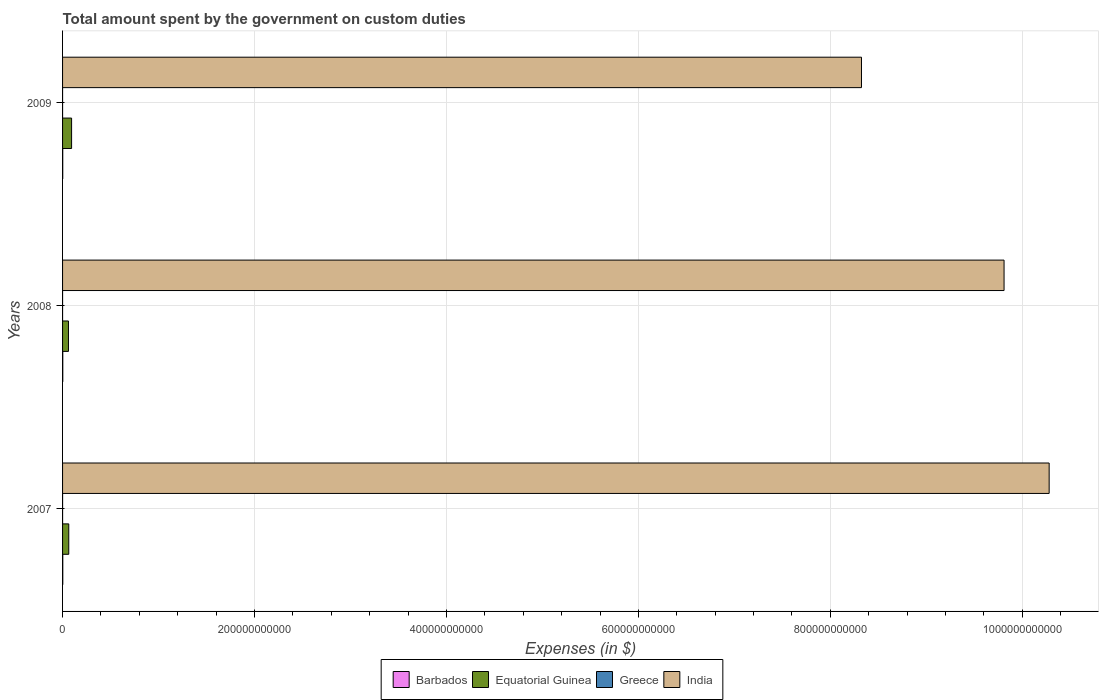How many different coloured bars are there?
Keep it short and to the point. 4. How many groups of bars are there?
Offer a terse response. 3. Are the number of bars on each tick of the Y-axis equal?
Your answer should be compact. Yes. How many bars are there on the 3rd tick from the bottom?
Make the answer very short. 4. What is the label of the 1st group of bars from the top?
Make the answer very short. 2009. What is the amount spent on custom duties by the government in Equatorial Guinea in 2007?
Provide a succinct answer. 6.46e+09. Across all years, what is the maximum amount spent on custom duties by the government in Equatorial Guinea?
Offer a terse response. 9.40e+09. Across all years, what is the minimum amount spent on custom duties by the government in Barbados?
Your response must be concise. 1.78e+08. In which year was the amount spent on custom duties by the government in Greece maximum?
Keep it short and to the point. 2007. What is the total amount spent on custom duties by the government in Greece in the graph?
Ensure brevity in your answer.  1.00e+07. What is the difference between the amount spent on custom duties by the government in Barbados in 2007 and that in 2008?
Provide a short and direct response. -2.52e+06. What is the difference between the amount spent on custom duties by the government in Equatorial Guinea in 2009 and the amount spent on custom duties by the government in India in 2007?
Keep it short and to the point. -1.02e+12. What is the average amount spent on custom duties by the government in Barbados per year?
Provide a succinct answer. 2.05e+08. In the year 2007, what is the difference between the amount spent on custom duties by the government in Equatorial Guinea and amount spent on custom duties by the government in Greece?
Your response must be concise. 6.45e+09. In how many years, is the amount spent on custom duties by the government in Barbados greater than 720000000000 $?
Your response must be concise. 0. What is the ratio of the amount spent on custom duties by the government in Barbados in 2007 to that in 2009?
Keep it short and to the point. 1.22. Is the amount spent on custom duties by the government in Equatorial Guinea in 2007 less than that in 2009?
Offer a terse response. Yes. What is the difference between the highest and the second highest amount spent on custom duties by the government in India?
Provide a succinct answer. 4.70e+1. What is the difference between the highest and the lowest amount spent on custom duties by the government in Barbados?
Provide a succinct answer. 4.15e+07. What does the 2nd bar from the bottom in 2008 represents?
Give a very brief answer. Equatorial Guinea. Is it the case that in every year, the sum of the amount spent on custom duties by the government in Barbados and amount spent on custom duties by the government in Greece is greater than the amount spent on custom duties by the government in Equatorial Guinea?
Ensure brevity in your answer.  No. Are all the bars in the graph horizontal?
Your answer should be very brief. Yes. What is the difference between two consecutive major ticks on the X-axis?
Provide a short and direct response. 2.00e+11. Are the values on the major ticks of X-axis written in scientific E-notation?
Provide a short and direct response. No. Does the graph contain any zero values?
Your response must be concise. No. Where does the legend appear in the graph?
Your answer should be compact. Bottom center. How many legend labels are there?
Give a very brief answer. 4. How are the legend labels stacked?
Ensure brevity in your answer.  Horizontal. What is the title of the graph?
Your response must be concise. Total amount spent by the government on custom duties. Does "Arab World" appear as one of the legend labels in the graph?
Give a very brief answer. No. What is the label or title of the X-axis?
Make the answer very short. Expenses (in $). What is the Expenses (in $) of Barbados in 2007?
Offer a terse response. 2.17e+08. What is the Expenses (in $) in Equatorial Guinea in 2007?
Offer a very short reply. 6.46e+09. What is the Expenses (in $) in India in 2007?
Provide a succinct answer. 1.03e+12. What is the Expenses (in $) in Barbados in 2008?
Offer a very short reply. 2.19e+08. What is the Expenses (in $) in Equatorial Guinea in 2008?
Your response must be concise. 6.14e+09. What is the Expenses (in $) in India in 2008?
Your answer should be compact. 9.81e+11. What is the Expenses (in $) in Barbados in 2009?
Provide a short and direct response. 1.78e+08. What is the Expenses (in $) in Equatorial Guinea in 2009?
Make the answer very short. 9.40e+09. What is the Expenses (in $) in Greece in 2009?
Provide a succinct answer. 1.00e+06. What is the Expenses (in $) of India in 2009?
Offer a terse response. 8.32e+11. Across all years, what is the maximum Expenses (in $) in Barbados?
Make the answer very short. 2.19e+08. Across all years, what is the maximum Expenses (in $) in Equatorial Guinea?
Offer a terse response. 9.40e+09. Across all years, what is the maximum Expenses (in $) of Greece?
Your answer should be very brief. 7.00e+06. Across all years, what is the maximum Expenses (in $) of India?
Offer a terse response. 1.03e+12. Across all years, what is the minimum Expenses (in $) in Barbados?
Provide a short and direct response. 1.78e+08. Across all years, what is the minimum Expenses (in $) of Equatorial Guinea?
Give a very brief answer. 6.14e+09. Across all years, what is the minimum Expenses (in $) of India?
Ensure brevity in your answer.  8.32e+11. What is the total Expenses (in $) of Barbados in the graph?
Offer a very short reply. 6.14e+08. What is the total Expenses (in $) in Equatorial Guinea in the graph?
Make the answer very short. 2.20e+1. What is the total Expenses (in $) in Greece in the graph?
Provide a short and direct response. 1.00e+07. What is the total Expenses (in $) in India in the graph?
Provide a short and direct response. 2.84e+12. What is the difference between the Expenses (in $) in Barbados in 2007 and that in 2008?
Your response must be concise. -2.52e+06. What is the difference between the Expenses (in $) in Equatorial Guinea in 2007 and that in 2008?
Keep it short and to the point. 3.15e+08. What is the difference between the Expenses (in $) of India in 2007 and that in 2008?
Offer a very short reply. 4.70e+1. What is the difference between the Expenses (in $) of Barbados in 2007 and that in 2009?
Ensure brevity in your answer.  3.90e+07. What is the difference between the Expenses (in $) of Equatorial Guinea in 2007 and that in 2009?
Your response must be concise. -2.94e+09. What is the difference between the Expenses (in $) in India in 2007 and that in 2009?
Provide a succinct answer. 1.96e+11. What is the difference between the Expenses (in $) in Barbados in 2008 and that in 2009?
Offer a terse response. 4.15e+07. What is the difference between the Expenses (in $) in Equatorial Guinea in 2008 and that in 2009?
Make the answer very short. -3.26e+09. What is the difference between the Expenses (in $) in India in 2008 and that in 2009?
Offer a very short reply. 1.49e+11. What is the difference between the Expenses (in $) of Barbados in 2007 and the Expenses (in $) of Equatorial Guinea in 2008?
Your response must be concise. -5.93e+09. What is the difference between the Expenses (in $) in Barbados in 2007 and the Expenses (in $) in Greece in 2008?
Give a very brief answer. 2.15e+08. What is the difference between the Expenses (in $) of Barbados in 2007 and the Expenses (in $) of India in 2008?
Offer a terse response. -9.81e+11. What is the difference between the Expenses (in $) in Equatorial Guinea in 2007 and the Expenses (in $) in Greece in 2008?
Keep it short and to the point. 6.46e+09. What is the difference between the Expenses (in $) of Equatorial Guinea in 2007 and the Expenses (in $) of India in 2008?
Provide a succinct answer. -9.75e+11. What is the difference between the Expenses (in $) in Greece in 2007 and the Expenses (in $) in India in 2008?
Keep it short and to the point. -9.81e+11. What is the difference between the Expenses (in $) of Barbados in 2007 and the Expenses (in $) of Equatorial Guinea in 2009?
Offer a terse response. -9.19e+09. What is the difference between the Expenses (in $) of Barbados in 2007 and the Expenses (in $) of Greece in 2009?
Make the answer very short. 2.16e+08. What is the difference between the Expenses (in $) in Barbados in 2007 and the Expenses (in $) in India in 2009?
Your answer should be very brief. -8.32e+11. What is the difference between the Expenses (in $) in Equatorial Guinea in 2007 and the Expenses (in $) in Greece in 2009?
Provide a succinct answer. 6.46e+09. What is the difference between the Expenses (in $) of Equatorial Guinea in 2007 and the Expenses (in $) of India in 2009?
Your response must be concise. -8.26e+11. What is the difference between the Expenses (in $) in Greece in 2007 and the Expenses (in $) in India in 2009?
Offer a very short reply. -8.32e+11. What is the difference between the Expenses (in $) of Barbados in 2008 and the Expenses (in $) of Equatorial Guinea in 2009?
Make the answer very short. -9.18e+09. What is the difference between the Expenses (in $) in Barbados in 2008 and the Expenses (in $) in Greece in 2009?
Provide a short and direct response. 2.18e+08. What is the difference between the Expenses (in $) of Barbados in 2008 and the Expenses (in $) of India in 2009?
Offer a very short reply. -8.32e+11. What is the difference between the Expenses (in $) of Equatorial Guinea in 2008 and the Expenses (in $) of Greece in 2009?
Offer a very short reply. 6.14e+09. What is the difference between the Expenses (in $) in Equatorial Guinea in 2008 and the Expenses (in $) in India in 2009?
Keep it short and to the point. -8.26e+11. What is the difference between the Expenses (in $) of Greece in 2008 and the Expenses (in $) of India in 2009?
Your response must be concise. -8.32e+11. What is the average Expenses (in $) in Barbados per year?
Your answer should be very brief. 2.05e+08. What is the average Expenses (in $) of Equatorial Guinea per year?
Ensure brevity in your answer.  7.34e+09. What is the average Expenses (in $) in Greece per year?
Provide a short and direct response. 3.33e+06. What is the average Expenses (in $) in India per year?
Your answer should be very brief. 9.47e+11. In the year 2007, what is the difference between the Expenses (in $) of Barbados and Expenses (in $) of Equatorial Guinea?
Offer a terse response. -6.24e+09. In the year 2007, what is the difference between the Expenses (in $) of Barbados and Expenses (in $) of Greece?
Provide a short and direct response. 2.10e+08. In the year 2007, what is the difference between the Expenses (in $) in Barbados and Expenses (in $) in India?
Provide a succinct answer. -1.03e+12. In the year 2007, what is the difference between the Expenses (in $) in Equatorial Guinea and Expenses (in $) in Greece?
Your answer should be compact. 6.45e+09. In the year 2007, what is the difference between the Expenses (in $) in Equatorial Guinea and Expenses (in $) in India?
Provide a succinct answer. -1.02e+12. In the year 2007, what is the difference between the Expenses (in $) of Greece and Expenses (in $) of India?
Make the answer very short. -1.03e+12. In the year 2008, what is the difference between the Expenses (in $) of Barbados and Expenses (in $) of Equatorial Guinea?
Give a very brief answer. -5.93e+09. In the year 2008, what is the difference between the Expenses (in $) in Barbados and Expenses (in $) in Greece?
Provide a succinct answer. 2.17e+08. In the year 2008, what is the difference between the Expenses (in $) of Barbados and Expenses (in $) of India?
Provide a succinct answer. -9.81e+11. In the year 2008, what is the difference between the Expenses (in $) of Equatorial Guinea and Expenses (in $) of Greece?
Ensure brevity in your answer.  6.14e+09. In the year 2008, what is the difference between the Expenses (in $) of Equatorial Guinea and Expenses (in $) of India?
Your answer should be very brief. -9.75e+11. In the year 2008, what is the difference between the Expenses (in $) of Greece and Expenses (in $) of India?
Provide a short and direct response. -9.81e+11. In the year 2009, what is the difference between the Expenses (in $) in Barbados and Expenses (in $) in Equatorial Guinea?
Offer a very short reply. -9.23e+09. In the year 2009, what is the difference between the Expenses (in $) in Barbados and Expenses (in $) in Greece?
Your response must be concise. 1.77e+08. In the year 2009, what is the difference between the Expenses (in $) in Barbados and Expenses (in $) in India?
Offer a terse response. -8.32e+11. In the year 2009, what is the difference between the Expenses (in $) in Equatorial Guinea and Expenses (in $) in Greece?
Your answer should be compact. 9.40e+09. In the year 2009, what is the difference between the Expenses (in $) in Equatorial Guinea and Expenses (in $) in India?
Provide a succinct answer. -8.23e+11. In the year 2009, what is the difference between the Expenses (in $) of Greece and Expenses (in $) of India?
Provide a succinct answer. -8.32e+11. What is the ratio of the Expenses (in $) in Equatorial Guinea in 2007 to that in 2008?
Keep it short and to the point. 1.05. What is the ratio of the Expenses (in $) of India in 2007 to that in 2008?
Your response must be concise. 1.05. What is the ratio of the Expenses (in $) of Barbados in 2007 to that in 2009?
Make the answer very short. 1.22. What is the ratio of the Expenses (in $) of Equatorial Guinea in 2007 to that in 2009?
Give a very brief answer. 0.69. What is the ratio of the Expenses (in $) in Greece in 2007 to that in 2009?
Your answer should be very brief. 7. What is the ratio of the Expenses (in $) of India in 2007 to that in 2009?
Your answer should be compact. 1.23. What is the ratio of the Expenses (in $) of Barbados in 2008 to that in 2009?
Offer a terse response. 1.23. What is the ratio of the Expenses (in $) of Equatorial Guinea in 2008 to that in 2009?
Give a very brief answer. 0.65. What is the ratio of the Expenses (in $) of Greece in 2008 to that in 2009?
Give a very brief answer. 2. What is the ratio of the Expenses (in $) of India in 2008 to that in 2009?
Offer a terse response. 1.18. What is the difference between the highest and the second highest Expenses (in $) of Barbados?
Provide a short and direct response. 2.52e+06. What is the difference between the highest and the second highest Expenses (in $) of Equatorial Guinea?
Offer a terse response. 2.94e+09. What is the difference between the highest and the second highest Expenses (in $) of Greece?
Your response must be concise. 5.00e+06. What is the difference between the highest and the second highest Expenses (in $) of India?
Give a very brief answer. 4.70e+1. What is the difference between the highest and the lowest Expenses (in $) in Barbados?
Provide a succinct answer. 4.15e+07. What is the difference between the highest and the lowest Expenses (in $) in Equatorial Guinea?
Your response must be concise. 3.26e+09. What is the difference between the highest and the lowest Expenses (in $) in Greece?
Keep it short and to the point. 6.00e+06. What is the difference between the highest and the lowest Expenses (in $) in India?
Make the answer very short. 1.96e+11. 